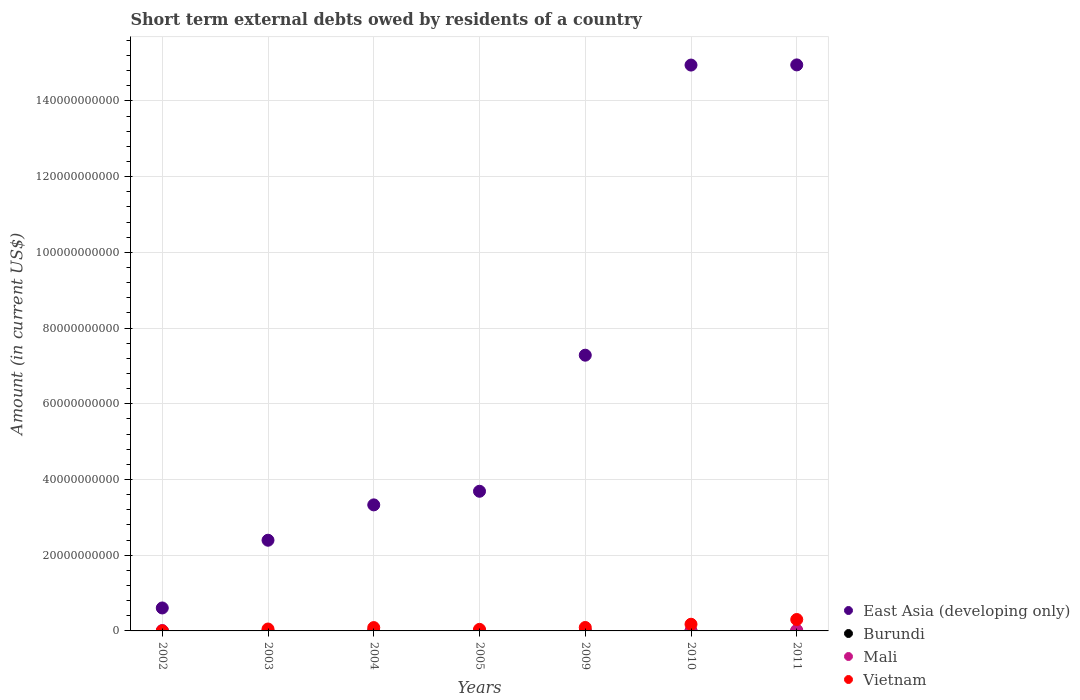How many different coloured dotlines are there?
Make the answer very short. 4. Is the number of dotlines equal to the number of legend labels?
Your answer should be compact. No. What is the amount of short-term external debts owed by residents in East Asia (developing only) in 2010?
Your response must be concise. 1.49e+11. Across all years, what is the maximum amount of short-term external debts owed by residents in Burundi?
Offer a very short reply. 8.00e+06. Across all years, what is the minimum amount of short-term external debts owed by residents in Vietnam?
Your answer should be very brief. 1.53e+06. In which year was the amount of short-term external debts owed by residents in East Asia (developing only) maximum?
Provide a short and direct response. 2011. What is the total amount of short-term external debts owed by residents in Burundi in the graph?
Your answer should be compact. 1.10e+07. What is the difference between the amount of short-term external debts owed by residents in Vietnam in 2002 and that in 2005?
Keep it short and to the point. -4.11e+08. What is the difference between the amount of short-term external debts owed by residents in Vietnam in 2002 and the amount of short-term external debts owed by residents in East Asia (developing only) in 2005?
Give a very brief answer. -3.69e+1. What is the average amount of short-term external debts owed by residents in Mali per year?
Your answer should be very brief. 4.43e+07. In the year 2002, what is the difference between the amount of short-term external debts owed by residents in Mali and amount of short-term external debts owed by residents in Vietnam?
Offer a terse response. 9.55e+07. In how many years, is the amount of short-term external debts owed by residents in Burundi greater than 32000000000 US$?
Offer a terse response. 0. What is the ratio of the amount of short-term external debts owed by residents in Vietnam in 2005 to that in 2011?
Provide a short and direct response. 0.14. Is the amount of short-term external debts owed by residents in Vietnam in 2003 less than that in 2004?
Your response must be concise. Yes. What is the difference between the highest and the second highest amount of short-term external debts owed by residents in Vietnam?
Your response must be concise. 1.25e+09. What is the difference between the highest and the lowest amount of short-term external debts owed by residents in Mali?
Keep it short and to the point. 1.69e+08. In how many years, is the amount of short-term external debts owed by residents in Vietnam greater than the average amount of short-term external debts owed by residents in Vietnam taken over all years?
Your answer should be very brief. 2. Is the sum of the amount of short-term external debts owed by residents in Vietnam in 2010 and 2011 greater than the maximum amount of short-term external debts owed by residents in Burundi across all years?
Your response must be concise. Yes. Is it the case that in every year, the sum of the amount of short-term external debts owed by residents in Burundi and amount of short-term external debts owed by residents in Mali  is greater than the sum of amount of short-term external debts owed by residents in Vietnam and amount of short-term external debts owed by residents in East Asia (developing only)?
Provide a short and direct response. No. Is the amount of short-term external debts owed by residents in Burundi strictly greater than the amount of short-term external debts owed by residents in Vietnam over the years?
Provide a short and direct response. No. How many dotlines are there?
Your answer should be compact. 4. How many years are there in the graph?
Ensure brevity in your answer.  7. What is the difference between two consecutive major ticks on the Y-axis?
Give a very brief answer. 2.00e+1. Are the values on the major ticks of Y-axis written in scientific E-notation?
Your answer should be compact. No. How are the legend labels stacked?
Keep it short and to the point. Vertical. What is the title of the graph?
Your response must be concise. Short term external debts owed by residents of a country. What is the Amount (in current US$) of East Asia (developing only) in 2002?
Your answer should be very brief. 6.06e+09. What is the Amount (in current US$) of Burundi in 2002?
Give a very brief answer. 0. What is the Amount (in current US$) of Mali in 2002?
Your response must be concise. 9.70e+07. What is the Amount (in current US$) of Vietnam in 2002?
Your answer should be very brief. 1.53e+06. What is the Amount (in current US$) of East Asia (developing only) in 2003?
Offer a terse response. 2.40e+1. What is the Amount (in current US$) in Burundi in 2003?
Your response must be concise. 0. What is the Amount (in current US$) in Vietnam in 2003?
Make the answer very short. 5.02e+08. What is the Amount (in current US$) in East Asia (developing only) in 2004?
Your answer should be very brief. 3.33e+1. What is the Amount (in current US$) in Burundi in 2004?
Your response must be concise. 3.00e+06. What is the Amount (in current US$) in Mali in 2004?
Provide a short and direct response. 1.50e+07. What is the Amount (in current US$) in Vietnam in 2004?
Offer a terse response. 8.80e+08. What is the Amount (in current US$) of East Asia (developing only) in 2005?
Offer a very short reply. 3.69e+1. What is the Amount (in current US$) of Mali in 2005?
Offer a very short reply. 5.00e+06. What is the Amount (in current US$) in Vietnam in 2005?
Offer a very short reply. 4.13e+08. What is the Amount (in current US$) in East Asia (developing only) in 2009?
Give a very brief answer. 7.28e+1. What is the Amount (in current US$) of Mali in 2009?
Your answer should be compact. 2.40e+07. What is the Amount (in current US$) of Vietnam in 2009?
Offer a very short reply. 9.08e+08. What is the Amount (in current US$) of East Asia (developing only) in 2010?
Make the answer very short. 1.49e+11. What is the Amount (in current US$) in Vietnam in 2010?
Give a very brief answer. 1.76e+09. What is the Amount (in current US$) in East Asia (developing only) in 2011?
Provide a succinct answer. 1.49e+11. What is the Amount (in current US$) in Mali in 2011?
Provide a succinct answer. 1.69e+08. What is the Amount (in current US$) in Vietnam in 2011?
Give a very brief answer. 3.02e+09. Across all years, what is the maximum Amount (in current US$) of East Asia (developing only)?
Provide a succinct answer. 1.49e+11. Across all years, what is the maximum Amount (in current US$) of Burundi?
Provide a short and direct response. 8.00e+06. Across all years, what is the maximum Amount (in current US$) in Mali?
Provide a succinct answer. 1.69e+08. Across all years, what is the maximum Amount (in current US$) in Vietnam?
Your answer should be very brief. 3.02e+09. Across all years, what is the minimum Amount (in current US$) of East Asia (developing only)?
Your answer should be very brief. 6.06e+09. Across all years, what is the minimum Amount (in current US$) in Vietnam?
Ensure brevity in your answer.  1.53e+06. What is the total Amount (in current US$) in East Asia (developing only) in the graph?
Your response must be concise. 4.72e+11. What is the total Amount (in current US$) in Burundi in the graph?
Your answer should be compact. 1.10e+07. What is the total Amount (in current US$) in Mali in the graph?
Offer a terse response. 3.10e+08. What is the total Amount (in current US$) of Vietnam in the graph?
Provide a short and direct response. 7.48e+09. What is the difference between the Amount (in current US$) in East Asia (developing only) in 2002 and that in 2003?
Your answer should be very brief. -1.79e+1. What is the difference between the Amount (in current US$) in Vietnam in 2002 and that in 2003?
Offer a terse response. -5.00e+08. What is the difference between the Amount (in current US$) of East Asia (developing only) in 2002 and that in 2004?
Your answer should be compact. -2.72e+1. What is the difference between the Amount (in current US$) of Mali in 2002 and that in 2004?
Provide a succinct answer. 8.20e+07. What is the difference between the Amount (in current US$) of Vietnam in 2002 and that in 2004?
Your answer should be very brief. -8.79e+08. What is the difference between the Amount (in current US$) in East Asia (developing only) in 2002 and that in 2005?
Your answer should be compact. -3.08e+1. What is the difference between the Amount (in current US$) of Mali in 2002 and that in 2005?
Your response must be concise. 9.20e+07. What is the difference between the Amount (in current US$) of Vietnam in 2002 and that in 2005?
Your answer should be compact. -4.11e+08. What is the difference between the Amount (in current US$) of East Asia (developing only) in 2002 and that in 2009?
Offer a terse response. -6.68e+1. What is the difference between the Amount (in current US$) in Mali in 2002 and that in 2009?
Provide a succinct answer. 7.30e+07. What is the difference between the Amount (in current US$) of Vietnam in 2002 and that in 2009?
Your answer should be very brief. -9.06e+08. What is the difference between the Amount (in current US$) of East Asia (developing only) in 2002 and that in 2010?
Your answer should be compact. -1.43e+11. What is the difference between the Amount (in current US$) in Vietnam in 2002 and that in 2010?
Offer a very short reply. -1.76e+09. What is the difference between the Amount (in current US$) in East Asia (developing only) in 2002 and that in 2011?
Your answer should be compact. -1.43e+11. What is the difference between the Amount (in current US$) in Mali in 2002 and that in 2011?
Provide a short and direct response. -7.20e+07. What is the difference between the Amount (in current US$) in Vietnam in 2002 and that in 2011?
Offer a terse response. -3.01e+09. What is the difference between the Amount (in current US$) in East Asia (developing only) in 2003 and that in 2004?
Your answer should be compact. -9.34e+09. What is the difference between the Amount (in current US$) in Vietnam in 2003 and that in 2004?
Make the answer very short. -3.79e+08. What is the difference between the Amount (in current US$) in East Asia (developing only) in 2003 and that in 2005?
Keep it short and to the point. -1.29e+1. What is the difference between the Amount (in current US$) in Vietnam in 2003 and that in 2005?
Your answer should be compact. 8.86e+07. What is the difference between the Amount (in current US$) in East Asia (developing only) in 2003 and that in 2009?
Make the answer very short. -4.89e+1. What is the difference between the Amount (in current US$) of Vietnam in 2003 and that in 2009?
Keep it short and to the point. -4.06e+08. What is the difference between the Amount (in current US$) of East Asia (developing only) in 2003 and that in 2010?
Provide a succinct answer. -1.26e+11. What is the difference between the Amount (in current US$) of Vietnam in 2003 and that in 2010?
Offer a terse response. -1.26e+09. What is the difference between the Amount (in current US$) of East Asia (developing only) in 2003 and that in 2011?
Provide a succinct answer. -1.26e+11. What is the difference between the Amount (in current US$) of Vietnam in 2003 and that in 2011?
Your answer should be very brief. -2.51e+09. What is the difference between the Amount (in current US$) in East Asia (developing only) in 2004 and that in 2005?
Provide a succinct answer. -3.60e+09. What is the difference between the Amount (in current US$) of Mali in 2004 and that in 2005?
Provide a succinct answer. 1.00e+07. What is the difference between the Amount (in current US$) of Vietnam in 2004 and that in 2005?
Make the answer very short. 4.67e+08. What is the difference between the Amount (in current US$) in East Asia (developing only) in 2004 and that in 2009?
Your response must be concise. -3.95e+1. What is the difference between the Amount (in current US$) in Mali in 2004 and that in 2009?
Keep it short and to the point. -9.00e+06. What is the difference between the Amount (in current US$) in Vietnam in 2004 and that in 2009?
Make the answer very short. -2.79e+07. What is the difference between the Amount (in current US$) in East Asia (developing only) in 2004 and that in 2010?
Offer a terse response. -1.16e+11. What is the difference between the Amount (in current US$) in Burundi in 2004 and that in 2010?
Provide a succinct answer. -5.00e+06. What is the difference between the Amount (in current US$) in Vietnam in 2004 and that in 2010?
Offer a very short reply. -8.83e+08. What is the difference between the Amount (in current US$) of East Asia (developing only) in 2004 and that in 2011?
Give a very brief answer. -1.16e+11. What is the difference between the Amount (in current US$) in Mali in 2004 and that in 2011?
Your answer should be compact. -1.54e+08. What is the difference between the Amount (in current US$) in Vietnam in 2004 and that in 2011?
Make the answer very short. -2.13e+09. What is the difference between the Amount (in current US$) of East Asia (developing only) in 2005 and that in 2009?
Provide a succinct answer. -3.59e+1. What is the difference between the Amount (in current US$) in Mali in 2005 and that in 2009?
Offer a very short reply. -1.90e+07. What is the difference between the Amount (in current US$) of Vietnam in 2005 and that in 2009?
Your answer should be compact. -4.95e+08. What is the difference between the Amount (in current US$) of East Asia (developing only) in 2005 and that in 2010?
Give a very brief answer. -1.13e+11. What is the difference between the Amount (in current US$) in Vietnam in 2005 and that in 2010?
Your response must be concise. -1.35e+09. What is the difference between the Amount (in current US$) in East Asia (developing only) in 2005 and that in 2011?
Keep it short and to the point. -1.13e+11. What is the difference between the Amount (in current US$) of Mali in 2005 and that in 2011?
Ensure brevity in your answer.  -1.64e+08. What is the difference between the Amount (in current US$) in Vietnam in 2005 and that in 2011?
Ensure brevity in your answer.  -2.60e+09. What is the difference between the Amount (in current US$) of East Asia (developing only) in 2009 and that in 2010?
Offer a very short reply. -7.66e+1. What is the difference between the Amount (in current US$) of Vietnam in 2009 and that in 2010?
Make the answer very short. -8.55e+08. What is the difference between the Amount (in current US$) in East Asia (developing only) in 2009 and that in 2011?
Make the answer very short. -7.67e+1. What is the difference between the Amount (in current US$) in Mali in 2009 and that in 2011?
Your response must be concise. -1.45e+08. What is the difference between the Amount (in current US$) of Vietnam in 2009 and that in 2011?
Provide a short and direct response. -2.11e+09. What is the difference between the Amount (in current US$) in East Asia (developing only) in 2010 and that in 2011?
Provide a succinct answer. -4.58e+07. What is the difference between the Amount (in current US$) of Vietnam in 2010 and that in 2011?
Offer a very short reply. -1.25e+09. What is the difference between the Amount (in current US$) of East Asia (developing only) in 2002 and the Amount (in current US$) of Vietnam in 2003?
Make the answer very short. 5.56e+09. What is the difference between the Amount (in current US$) of Mali in 2002 and the Amount (in current US$) of Vietnam in 2003?
Offer a terse response. -4.05e+08. What is the difference between the Amount (in current US$) in East Asia (developing only) in 2002 and the Amount (in current US$) in Burundi in 2004?
Give a very brief answer. 6.06e+09. What is the difference between the Amount (in current US$) in East Asia (developing only) in 2002 and the Amount (in current US$) in Mali in 2004?
Provide a succinct answer. 6.05e+09. What is the difference between the Amount (in current US$) in East Asia (developing only) in 2002 and the Amount (in current US$) in Vietnam in 2004?
Give a very brief answer. 5.18e+09. What is the difference between the Amount (in current US$) of Mali in 2002 and the Amount (in current US$) of Vietnam in 2004?
Offer a terse response. -7.83e+08. What is the difference between the Amount (in current US$) of East Asia (developing only) in 2002 and the Amount (in current US$) of Mali in 2005?
Your answer should be very brief. 6.06e+09. What is the difference between the Amount (in current US$) of East Asia (developing only) in 2002 and the Amount (in current US$) of Vietnam in 2005?
Your answer should be very brief. 5.65e+09. What is the difference between the Amount (in current US$) in Mali in 2002 and the Amount (in current US$) in Vietnam in 2005?
Your answer should be very brief. -3.16e+08. What is the difference between the Amount (in current US$) of East Asia (developing only) in 2002 and the Amount (in current US$) of Mali in 2009?
Offer a very short reply. 6.04e+09. What is the difference between the Amount (in current US$) in East Asia (developing only) in 2002 and the Amount (in current US$) in Vietnam in 2009?
Provide a succinct answer. 5.16e+09. What is the difference between the Amount (in current US$) in Mali in 2002 and the Amount (in current US$) in Vietnam in 2009?
Your answer should be compact. -8.11e+08. What is the difference between the Amount (in current US$) in East Asia (developing only) in 2002 and the Amount (in current US$) in Burundi in 2010?
Your answer should be very brief. 6.06e+09. What is the difference between the Amount (in current US$) of East Asia (developing only) in 2002 and the Amount (in current US$) of Vietnam in 2010?
Give a very brief answer. 4.30e+09. What is the difference between the Amount (in current US$) of Mali in 2002 and the Amount (in current US$) of Vietnam in 2010?
Offer a terse response. -1.67e+09. What is the difference between the Amount (in current US$) of East Asia (developing only) in 2002 and the Amount (in current US$) of Mali in 2011?
Provide a short and direct response. 5.89e+09. What is the difference between the Amount (in current US$) of East Asia (developing only) in 2002 and the Amount (in current US$) of Vietnam in 2011?
Keep it short and to the point. 3.05e+09. What is the difference between the Amount (in current US$) in Mali in 2002 and the Amount (in current US$) in Vietnam in 2011?
Offer a terse response. -2.92e+09. What is the difference between the Amount (in current US$) of East Asia (developing only) in 2003 and the Amount (in current US$) of Burundi in 2004?
Keep it short and to the point. 2.39e+1. What is the difference between the Amount (in current US$) of East Asia (developing only) in 2003 and the Amount (in current US$) of Mali in 2004?
Your answer should be very brief. 2.39e+1. What is the difference between the Amount (in current US$) of East Asia (developing only) in 2003 and the Amount (in current US$) of Vietnam in 2004?
Provide a short and direct response. 2.31e+1. What is the difference between the Amount (in current US$) of East Asia (developing only) in 2003 and the Amount (in current US$) of Mali in 2005?
Provide a short and direct response. 2.39e+1. What is the difference between the Amount (in current US$) of East Asia (developing only) in 2003 and the Amount (in current US$) of Vietnam in 2005?
Keep it short and to the point. 2.35e+1. What is the difference between the Amount (in current US$) in East Asia (developing only) in 2003 and the Amount (in current US$) in Mali in 2009?
Give a very brief answer. 2.39e+1. What is the difference between the Amount (in current US$) of East Asia (developing only) in 2003 and the Amount (in current US$) of Vietnam in 2009?
Provide a succinct answer. 2.30e+1. What is the difference between the Amount (in current US$) in East Asia (developing only) in 2003 and the Amount (in current US$) in Burundi in 2010?
Provide a short and direct response. 2.39e+1. What is the difference between the Amount (in current US$) of East Asia (developing only) in 2003 and the Amount (in current US$) of Vietnam in 2010?
Provide a short and direct response. 2.22e+1. What is the difference between the Amount (in current US$) of East Asia (developing only) in 2003 and the Amount (in current US$) of Mali in 2011?
Your answer should be very brief. 2.38e+1. What is the difference between the Amount (in current US$) in East Asia (developing only) in 2003 and the Amount (in current US$) in Vietnam in 2011?
Offer a terse response. 2.09e+1. What is the difference between the Amount (in current US$) of East Asia (developing only) in 2004 and the Amount (in current US$) of Mali in 2005?
Your response must be concise. 3.33e+1. What is the difference between the Amount (in current US$) of East Asia (developing only) in 2004 and the Amount (in current US$) of Vietnam in 2005?
Give a very brief answer. 3.29e+1. What is the difference between the Amount (in current US$) of Burundi in 2004 and the Amount (in current US$) of Vietnam in 2005?
Provide a succinct answer. -4.10e+08. What is the difference between the Amount (in current US$) in Mali in 2004 and the Amount (in current US$) in Vietnam in 2005?
Give a very brief answer. -3.98e+08. What is the difference between the Amount (in current US$) of East Asia (developing only) in 2004 and the Amount (in current US$) of Mali in 2009?
Your answer should be compact. 3.33e+1. What is the difference between the Amount (in current US$) in East Asia (developing only) in 2004 and the Amount (in current US$) in Vietnam in 2009?
Provide a succinct answer. 3.24e+1. What is the difference between the Amount (in current US$) of Burundi in 2004 and the Amount (in current US$) of Mali in 2009?
Your answer should be compact. -2.10e+07. What is the difference between the Amount (in current US$) in Burundi in 2004 and the Amount (in current US$) in Vietnam in 2009?
Offer a terse response. -9.05e+08. What is the difference between the Amount (in current US$) in Mali in 2004 and the Amount (in current US$) in Vietnam in 2009?
Offer a very short reply. -8.93e+08. What is the difference between the Amount (in current US$) of East Asia (developing only) in 2004 and the Amount (in current US$) of Burundi in 2010?
Your response must be concise. 3.33e+1. What is the difference between the Amount (in current US$) in East Asia (developing only) in 2004 and the Amount (in current US$) in Vietnam in 2010?
Provide a short and direct response. 3.15e+1. What is the difference between the Amount (in current US$) of Burundi in 2004 and the Amount (in current US$) of Vietnam in 2010?
Give a very brief answer. -1.76e+09. What is the difference between the Amount (in current US$) of Mali in 2004 and the Amount (in current US$) of Vietnam in 2010?
Provide a short and direct response. -1.75e+09. What is the difference between the Amount (in current US$) in East Asia (developing only) in 2004 and the Amount (in current US$) in Mali in 2011?
Give a very brief answer. 3.31e+1. What is the difference between the Amount (in current US$) of East Asia (developing only) in 2004 and the Amount (in current US$) of Vietnam in 2011?
Ensure brevity in your answer.  3.03e+1. What is the difference between the Amount (in current US$) of Burundi in 2004 and the Amount (in current US$) of Mali in 2011?
Your answer should be compact. -1.66e+08. What is the difference between the Amount (in current US$) in Burundi in 2004 and the Amount (in current US$) in Vietnam in 2011?
Keep it short and to the point. -3.01e+09. What is the difference between the Amount (in current US$) of Mali in 2004 and the Amount (in current US$) of Vietnam in 2011?
Make the answer very short. -3.00e+09. What is the difference between the Amount (in current US$) of East Asia (developing only) in 2005 and the Amount (in current US$) of Mali in 2009?
Make the answer very short. 3.69e+1. What is the difference between the Amount (in current US$) of East Asia (developing only) in 2005 and the Amount (in current US$) of Vietnam in 2009?
Keep it short and to the point. 3.60e+1. What is the difference between the Amount (in current US$) of Mali in 2005 and the Amount (in current US$) of Vietnam in 2009?
Provide a short and direct response. -9.03e+08. What is the difference between the Amount (in current US$) of East Asia (developing only) in 2005 and the Amount (in current US$) of Burundi in 2010?
Ensure brevity in your answer.  3.69e+1. What is the difference between the Amount (in current US$) in East Asia (developing only) in 2005 and the Amount (in current US$) in Vietnam in 2010?
Your answer should be compact. 3.51e+1. What is the difference between the Amount (in current US$) of Mali in 2005 and the Amount (in current US$) of Vietnam in 2010?
Keep it short and to the point. -1.76e+09. What is the difference between the Amount (in current US$) of East Asia (developing only) in 2005 and the Amount (in current US$) of Mali in 2011?
Give a very brief answer. 3.67e+1. What is the difference between the Amount (in current US$) of East Asia (developing only) in 2005 and the Amount (in current US$) of Vietnam in 2011?
Keep it short and to the point. 3.39e+1. What is the difference between the Amount (in current US$) in Mali in 2005 and the Amount (in current US$) in Vietnam in 2011?
Your response must be concise. -3.01e+09. What is the difference between the Amount (in current US$) of East Asia (developing only) in 2009 and the Amount (in current US$) of Burundi in 2010?
Give a very brief answer. 7.28e+1. What is the difference between the Amount (in current US$) of East Asia (developing only) in 2009 and the Amount (in current US$) of Vietnam in 2010?
Offer a terse response. 7.11e+1. What is the difference between the Amount (in current US$) of Mali in 2009 and the Amount (in current US$) of Vietnam in 2010?
Your answer should be compact. -1.74e+09. What is the difference between the Amount (in current US$) of East Asia (developing only) in 2009 and the Amount (in current US$) of Mali in 2011?
Make the answer very short. 7.27e+1. What is the difference between the Amount (in current US$) in East Asia (developing only) in 2009 and the Amount (in current US$) in Vietnam in 2011?
Make the answer very short. 6.98e+1. What is the difference between the Amount (in current US$) in Mali in 2009 and the Amount (in current US$) in Vietnam in 2011?
Your answer should be very brief. -2.99e+09. What is the difference between the Amount (in current US$) in East Asia (developing only) in 2010 and the Amount (in current US$) in Mali in 2011?
Make the answer very short. 1.49e+11. What is the difference between the Amount (in current US$) of East Asia (developing only) in 2010 and the Amount (in current US$) of Vietnam in 2011?
Give a very brief answer. 1.46e+11. What is the difference between the Amount (in current US$) in Burundi in 2010 and the Amount (in current US$) in Mali in 2011?
Ensure brevity in your answer.  -1.61e+08. What is the difference between the Amount (in current US$) of Burundi in 2010 and the Amount (in current US$) of Vietnam in 2011?
Give a very brief answer. -3.01e+09. What is the average Amount (in current US$) of East Asia (developing only) per year?
Your answer should be very brief. 6.74e+1. What is the average Amount (in current US$) in Burundi per year?
Offer a terse response. 1.57e+06. What is the average Amount (in current US$) of Mali per year?
Give a very brief answer. 4.43e+07. What is the average Amount (in current US$) in Vietnam per year?
Ensure brevity in your answer.  1.07e+09. In the year 2002, what is the difference between the Amount (in current US$) of East Asia (developing only) and Amount (in current US$) of Mali?
Provide a succinct answer. 5.97e+09. In the year 2002, what is the difference between the Amount (in current US$) in East Asia (developing only) and Amount (in current US$) in Vietnam?
Offer a very short reply. 6.06e+09. In the year 2002, what is the difference between the Amount (in current US$) of Mali and Amount (in current US$) of Vietnam?
Your answer should be very brief. 9.55e+07. In the year 2003, what is the difference between the Amount (in current US$) in East Asia (developing only) and Amount (in current US$) in Vietnam?
Ensure brevity in your answer.  2.35e+1. In the year 2004, what is the difference between the Amount (in current US$) in East Asia (developing only) and Amount (in current US$) in Burundi?
Offer a terse response. 3.33e+1. In the year 2004, what is the difference between the Amount (in current US$) of East Asia (developing only) and Amount (in current US$) of Mali?
Your answer should be compact. 3.33e+1. In the year 2004, what is the difference between the Amount (in current US$) in East Asia (developing only) and Amount (in current US$) in Vietnam?
Give a very brief answer. 3.24e+1. In the year 2004, what is the difference between the Amount (in current US$) of Burundi and Amount (in current US$) of Mali?
Ensure brevity in your answer.  -1.20e+07. In the year 2004, what is the difference between the Amount (in current US$) in Burundi and Amount (in current US$) in Vietnam?
Provide a short and direct response. -8.77e+08. In the year 2004, what is the difference between the Amount (in current US$) of Mali and Amount (in current US$) of Vietnam?
Ensure brevity in your answer.  -8.65e+08. In the year 2005, what is the difference between the Amount (in current US$) in East Asia (developing only) and Amount (in current US$) in Mali?
Give a very brief answer. 3.69e+1. In the year 2005, what is the difference between the Amount (in current US$) in East Asia (developing only) and Amount (in current US$) in Vietnam?
Give a very brief answer. 3.65e+1. In the year 2005, what is the difference between the Amount (in current US$) in Mali and Amount (in current US$) in Vietnam?
Make the answer very short. -4.08e+08. In the year 2009, what is the difference between the Amount (in current US$) in East Asia (developing only) and Amount (in current US$) in Mali?
Your answer should be compact. 7.28e+1. In the year 2009, what is the difference between the Amount (in current US$) in East Asia (developing only) and Amount (in current US$) in Vietnam?
Make the answer very short. 7.19e+1. In the year 2009, what is the difference between the Amount (in current US$) in Mali and Amount (in current US$) in Vietnam?
Make the answer very short. -8.84e+08. In the year 2010, what is the difference between the Amount (in current US$) in East Asia (developing only) and Amount (in current US$) in Burundi?
Your answer should be compact. 1.49e+11. In the year 2010, what is the difference between the Amount (in current US$) in East Asia (developing only) and Amount (in current US$) in Vietnam?
Your answer should be very brief. 1.48e+11. In the year 2010, what is the difference between the Amount (in current US$) in Burundi and Amount (in current US$) in Vietnam?
Your answer should be compact. -1.76e+09. In the year 2011, what is the difference between the Amount (in current US$) in East Asia (developing only) and Amount (in current US$) in Mali?
Give a very brief answer. 1.49e+11. In the year 2011, what is the difference between the Amount (in current US$) in East Asia (developing only) and Amount (in current US$) in Vietnam?
Ensure brevity in your answer.  1.46e+11. In the year 2011, what is the difference between the Amount (in current US$) of Mali and Amount (in current US$) of Vietnam?
Make the answer very short. -2.85e+09. What is the ratio of the Amount (in current US$) in East Asia (developing only) in 2002 to that in 2003?
Your answer should be compact. 0.25. What is the ratio of the Amount (in current US$) of Vietnam in 2002 to that in 2003?
Ensure brevity in your answer.  0. What is the ratio of the Amount (in current US$) in East Asia (developing only) in 2002 to that in 2004?
Make the answer very short. 0.18. What is the ratio of the Amount (in current US$) in Mali in 2002 to that in 2004?
Offer a terse response. 6.47. What is the ratio of the Amount (in current US$) of Vietnam in 2002 to that in 2004?
Your response must be concise. 0. What is the ratio of the Amount (in current US$) of East Asia (developing only) in 2002 to that in 2005?
Offer a very short reply. 0.16. What is the ratio of the Amount (in current US$) of Mali in 2002 to that in 2005?
Ensure brevity in your answer.  19.4. What is the ratio of the Amount (in current US$) of Vietnam in 2002 to that in 2005?
Keep it short and to the point. 0. What is the ratio of the Amount (in current US$) in East Asia (developing only) in 2002 to that in 2009?
Keep it short and to the point. 0.08. What is the ratio of the Amount (in current US$) of Mali in 2002 to that in 2009?
Give a very brief answer. 4.04. What is the ratio of the Amount (in current US$) of Vietnam in 2002 to that in 2009?
Ensure brevity in your answer.  0. What is the ratio of the Amount (in current US$) in East Asia (developing only) in 2002 to that in 2010?
Make the answer very short. 0.04. What is the ratio of the Amount (in current US$) of Vietnam in 2002 to that in 2010?
Your answer should be very brief. 0. What is the ratio of the Amount (in current US$) in East Asia (developing only) in 2002 to that in 2011?
Your answer should be compact. 0.04. What is the ratio of the Amount (in current US$) of Mali in 2002 to that in 2011?
Provide a succinct answer. 0.57. What is the ratio of the Amount (in current US$) of Vietnam in 2002 to that in 2011?
Offer a very short reply. 0. What is the ratio of the Amount (in current US$) in East Asia (developing only) in 2003 to that in 2004?
Keep it short and to the point. 0.72. What is the ratio of the Amount (in current US$) in Vietnam in 2003 to that in 2004?
Your answer should be compact. 0.57. What is the ratio of the Amount (in current US$) in East Asia (developing only) in 2003 to that in 2005?
Ensure brevity in your answer.  0.65. What is the ratio of the Amount (in current US$) in Vietnam in 2003 to that in 2005?
Offer a terse response. 1.21. What is the ratio of the Amount (in current US$) of East Asia (developing only) in 2003 to that in 2009?
Offer a very short reply. 0.33. What is the ratio of the Amount (in current US$) of Vietnam in 2003 to that in 2009?
Provide a succinct answer. 0.55. What is the ratio of the Amount (in current US$) of East Asia (developing only) in 2003 to that in 2010?
Your answer should be very brief. 0.16. What is the ratio of the Amount (in current US$) in Vietnam in 2003 to that in 2010?
Your answer should be very brief. 0.28. What is the ratio of the Amount (in current US$) of East Asia (developing only) in 2003 to that in 2011?
Your response must be concise. 0.16. What is the ratio of the Amount (in current US$) in Vietnam in 2003 to that in 2011?
Offer a very short reply. 0.17. What is the ratio of the Amount (in current US$) in East Asia (developing only) in 2004 to that in 2005?
Provide a succinct answer. 0.9. What is the ratio of the Amount (in current US$) in Mali in 2004 to that in 2005?
Provide a short and direct response. 3. What is the ratio of the Amount (in current US$) in Vietnam in 2004 to that in 2005?
Ensure brevity in your answer.  2.13. What is the ratio of the Amount (in current US$) of East Asia (developing only) in 2004 to that in 2009?
Provide a succinct answer. 0.46. What is the ratio of the Amount (in current US$) of Vietnam in 2004 to that in 2009?
Provide a short and direct response. 0.97. What is the ratio of the Amount (in current US$) of East Asia (developing only) in 2004 to that in 2010?
Your answer should be compact. 0.22. What is the ratio of the Amount (in current US$) of Vietnam in 2004 to that in 2010?
Your answer should be compact. 0.5. What is the ratio of the Amount (in current US$) of East Asia (developing only) in 2004 to that in 2011?
Ensure brevity in your answer.  0.22. What is the ratio of the Amount (in current US$) of Mali in 2004 to that in 2011?
Your answer should be compact. 0.09. What is the ratio of the Amount (in current US$) in Vietnam in 2004 to that in 2011?
Give a very brief answer. 0.29. What is the ratio of the Amount (in current US$) of East Asia (developing only) in 2005 to that in 2009?
Offer a terse response. 0.51. What is the ratio of the Amount (in current US$) in Mali in 2005 to that in 2009?
Keep it short and to the point. 0.21. What is the ratio of the Amount (in current US$) of Vietnam in 2005 to that in 2009?
Your response must be concise. 0.45. What is the ratio of the Amount (in current US$) of East Asia (developing only) in 2005 to that in 2010?
Ensure brevity in your answer.  0.25. What is the ratio of the Amount (in current US$) of Vietnam in 2005 to that in 2010?
Give a very brief answer. 0.23. What is the ratio of the Amount (in current US$) of East Asia (developing only) in 2005 to that in 2011?
Make the answer very short. 0.25. What is the ratio of the Amount (in current US$) of Mali in 2005 to that in 2011?
Your answer should be very brief. 0.03. What is the ratio of the Amount (in current US$) of Vietnam in 2005 to that in 2011?
Ensure brevity in your answer.  0.14. What is the ratio of the Amount (in current US$) of East Asia (developing only) in 2009 to that in 2010?
Keep it short and to the point. 0.49. What is the ratio of the Amount (in current US$) of Vietnam in 2009 to that in 2010?
Your answer should be compact. 0.52. What is the ratio of the Amount (in current US$) in East Asia (developing only) in 2009 to that in 2011?
Ensure brevity in your answer.  0.49. What is the ratio of the Amount (in current US$) in Mali in 2009 to that in 2011?
Provide a short and direct response. 0.14. What is the ratio of the Amount (in current US$) of Vietnam in 2009 to that in 2011?
Provide a short and direct response. 0.3. What is the ratio of the Amount (in current US$) of Vietnam in 2010 to that in 2011?
Ensure brevity in your answer.  0.58. What is the difference between the highest and the second highest Amount (in current US$) of East Asia (developing only)?
Keep it short and to the point. 4.58e+07. What is the difference between the highest and the second highest Amount (in current US$) of Mali?
Your answer should be compact. 7.20e+07. What is the difference between the highest and the second highest Amount (in current US$) of Vietnam?
Your answer should be compact. 1.25e+09. What is the difference between the highest and the lowest Amount (in current US$) in East Asia (developing only)?
Offer a terse response. 1.43e+11. What is the difference between the highest and the lowest Amount (in current US$) in Burundi?
Keep it short and to the point. 8.00e+06. What is the difference between the highest and the lowest Amount (in current US$) in Mali?
Make the answer very short. 1.69e+08. What is the difference between the highest and the lowest Amount (in current US$) of Vietnam?
Keep it short and to the point. 3.01e+09. 